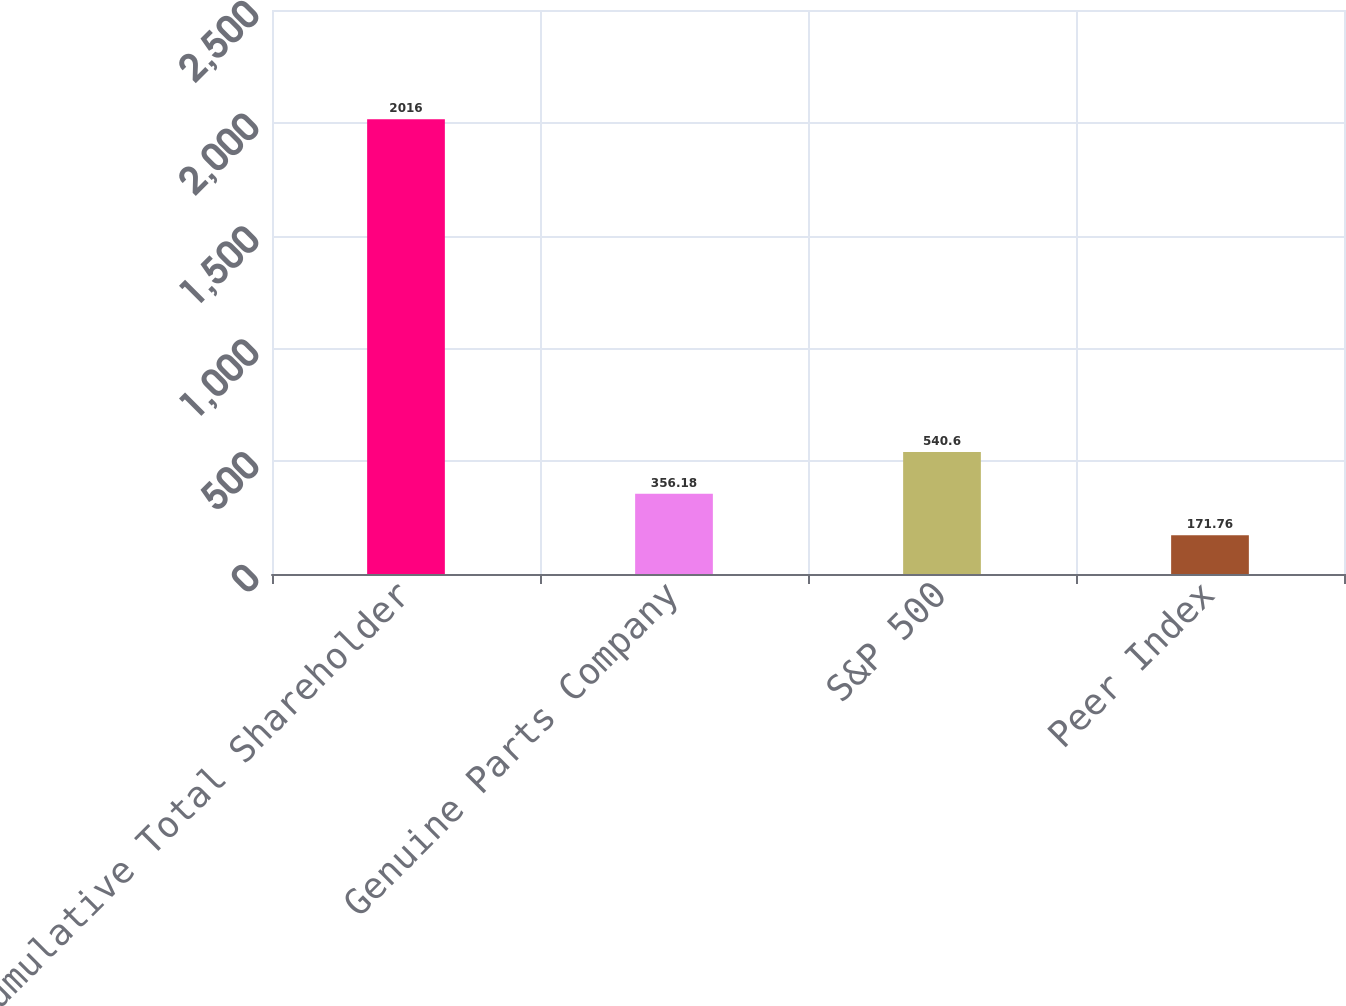<chart> <loc_0><loc_0><loc_500><loc_500><bar_chart><fcel>Cumulative Total Shareholder<fcel>Genuine Parts Company<fcel>S&P 500<fcel>Peer Index<nl><fcel>2016<fcel>356.18<fcel>540.6<fcel>171.76<nl></chart> 